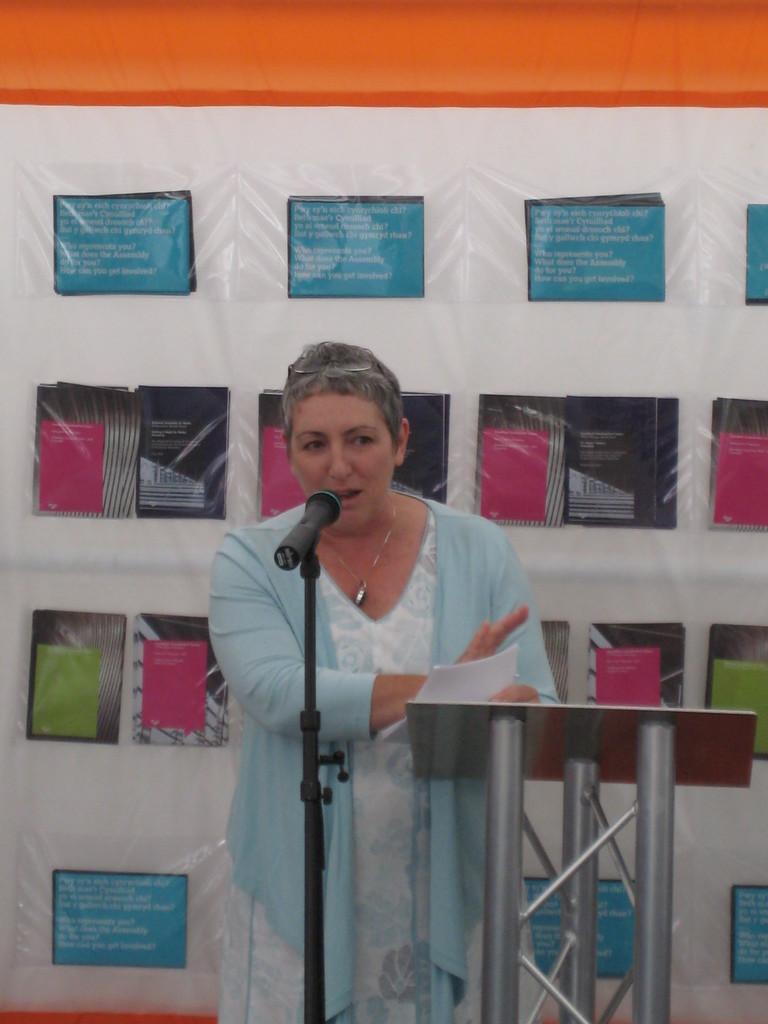Please provide a concise description of this image. In this image we can see a person standing and holding papers. In front of her we can see a microphone and stand. There is a banner with text and images in the background. 